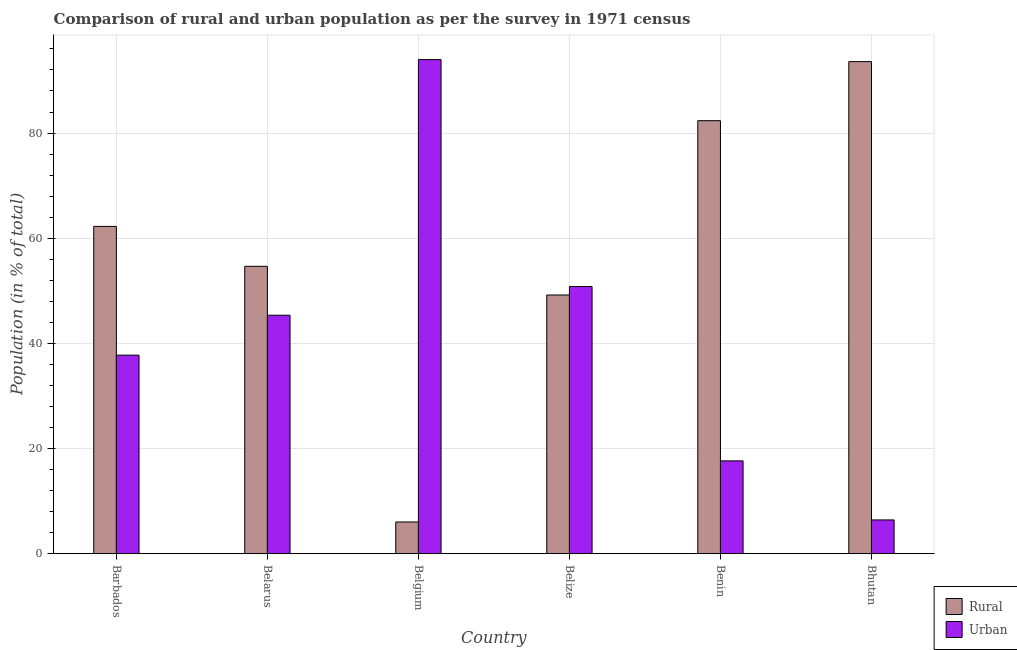How many groups of bars are there?
Make the answer very short. 6. Are the number of bars per tick equal to the number of legend labels?
Make the answer very short. Yes. Are the number of bars on each tick of the X-axis equal?
Your response must be concise. Yes. How many bars are there on the 4th tick from the right?
Give a very brief answer. 2. What is the label of the 5th group of bars from the left?
Your answer should be very brief. Benin. What is the urban population in Belize?
Offer a terse response. 50.8. Across all countries, what is the maximum rural population?
Give a very brief answer. 93.59. Across all countries, what is the minimum rural population?
Ensure brevity in your answer.  6.02. In which country was the urban population maximum?
Ensure brevity in your answer.  Belgium. In which country was the urban population minimum?
Make the answer very short. Bhutan. What is the total rural population in the graph?
Make the answer very short. 348.06. What is the difference between the urban population in Belgium and that in Bhutan?
Offer a terse response. 87.56. What is the difference between the urban population in Benin and the rural population in Belize?
Give a very brief answer. -31.55. What is the average rural population per country?
Offer a terse response. 58.01. What is the difference between the rural population and urban population in Bhutan?
Make the answer very short. 87.17. In how many countries, is the urban population greater than 88 %?
Provide a succinct answer. 1. What is the ratio of the rural population in Belarus to that in Belgium?
Give a very brief answer. 9.07. Is the rural population in Belize less than that in Benin?
Make the answer very short. Yes. What is the difference between the highest and the second highest urban population?
Offer a terse response. 43.17. What is the difference between the highest and the lowest rural population?
Make the answer very short. 87.56. In how many countries, is the rural population greater than the average rural population taken over all countries?
Make the answer very short. 3. What does the 2nd bar from the left in Benin represents?
Your response must be concise. Urban. What does the 1st bar from the right in Barbados represents?
Provide a short and direct response. Urban. How many bars are there?
Your answer should be compact. 12. Are all the bars in the graph horizontal?
Your answer should be compact. No. How many countries are there in the graph?
Keep it short and to the point. 6. Are the values on the major ticks of Y-axis written in scientific E-notation?
Provide a succinct answer. No. Does the graph contain grids?
Your response must be concise. Yes. Where does the legend appear in the graph?
Provide a short and direct response. Bottom right. What is the title of the graph?
Provide a short and direct response. Comparison of rural and urban population as per the survey in 1971 census. Does "Savings" appear as one of the legend labels in the graph?
Offer a very short reply. No. What is the label or title of the X-axis?
Your answer should be very brief. Country. What is the label or title of the Y-axis?
Ensure brevity in your answer.  Population (in % of total). What is the Population (in % of total) in Rural in Barbados?
Keep it short and to the point. 62.24. What is the Population (in % of total) of Urban in Barbados?
Make the answer very short. 37.76. What is the Population (in % of total) in Rural in Belarus?
Your answer should be compact. 54.65. What is the Population (in % of total) in Urban in Belarus?
Your answer should be very brief. 45.35. What is the Population (in % of total) in Rural in Belgium?
Provide a short and direct response. 6.02. What is the Population (in % of total) of Urban in Belgium?
Give a very brief answer. 93.98. What is the Population (in % of total) in Rural in Belize?
Ensure brevity in your answer.  49.2. What is the Population (in % of total) of Urban in Belize?
Offer a very short reply. 50.8. What is the Population (in % of total) of Rural in Benin?
Provide a succinct answer. 82.35. What is the Population (in % of total) of Urban in Benin?
Make the answer very short. 17.65. What is the Population (in % of total) in Rural in Bhutan?
Keep it short and to the point. 93.59. What is the Population (in % of total) of Urban in Bhutan?
Make the answer very short. 6.41. Across all countries, what is the maximum Population (in % of total) of Rural?
Your answer should be very brief. 93.59. Across all countries, what is the maximum Population (in % of total) in Urban?
Provide a short and direct response. 93.98. Across all countries, what is the minimum Population (in % of total) of Rural?
Provide a short and direct response. 6.02. Across all countries, what is the minimum Population (in % of total) in Urban?
Offer a very short reply. 6.41. What is the total Population (in % of total) in Rural in the graph?
Give a very brief answer. 348.06. What is the total Population (in % of total) of Urban in the graph?
Offer a terse response. 251.94. What is the difference between the Population (in % of total) in Rural in Barbados and that in Belarus?
Make the answer very short. 7.59. What is the difference between the Population (in % of total) in Urban in Barbados and that in Belarus?
Give a very brief answer. -7.59. What is the difference between the Population (in % of total) of Rural in Barbados and that in Belgium?
Provide a succinct answer. 56.22. What is the difference between the Population (in % of total) of Urban in Barbados and that in Belgium?
Keep it short and to the point. -56.22. What is the difference between the Population (in % of total) of Rural in Barbados and that in Belize?
Your answer should be compact. 13.05. What is the difference between the Population (in % of total) of Urban in Barbados and that in Belize?
Provide a short and direct response. -13.05. What is the difference between the Population (in % of total) in Rural in Barbados and that in Benin?
Offer a terse response. -20.11. What is the difference between the Population (in % of total) of Urban in Barbados and that in Benin?
Your response must be concise. 20.11. What is the difference between the Population (in % of total) of Rural in Barbados and that in Bhutan?
Provide a short and direct response. -31.34. What is the difference between the Population (in % of total) of Urban in Barbados and that in Bhutan?
Your response must be concise. 31.34. What is the difference between the Population (in % of total) in Rural in Belarus and that in Belgium?
Make the answer very short. 48.63. What is the difference between the Population (in % of total) in Urban in Belarus and that in Belgium?
Provide a succinct answer. -48.63. What is the difference between the Population (in % of total) in Rural in Belarus and that in Belize?
Your response must be concise. 5.46. What is the difference between the Population (in % of total) of Urban in Belarus and that in Belize?
Your response must be concise. -5.46. What is the difference between the Population (in % of total) of Rural in Belarus and that in Benin?
Your answer should be very brief. -27.7. What is the difference between the Population (in % of total) in Urban in Belarus and that in Benin?
Offer a very short reply. 27.7. What is the difference between the Population (in % of total) in Rural in Belarus and that in Bhutan?
Ensure brevity in your answer.  -38.94. What is the difference between the Population (in % of total) of Urban in Belarus and that in Bhutan?
Offer a very short reply. 38.94. What is the difference between the Population (in % of total) in Rural in Belgium and that in Belize?
Give a very brief answer. -43.17. What is the difference between the Population (in % of total) of Urban in Belgium and that in Belize?
Offer a terse response. 43.17. What is the difference between the Population (in % of total) in Rural in Belgium and that in Benin?
Provide a short and direct response. -76.33. What is the difference between the Population (in % of total) of Urban in Belgium and that in Benin?
Give a very brief answer. 76.33. What is the difference between the Population (in % of total) in Rural in Belgium and that in Bhutan?
Give a very brief answer. -87.56. What is the difference between the Population (in % of total) in Urban in Belgium and that in Bhutan?
Provide a short and direct response. 87.56. What is the difference between the Population (in % of total) in Rural in Belize and that in Benin?
Your answer should be very brief. -33.16. What is the difference between the Population (in % of total) in Urban in Belize and that in Benin?
Offer a very short reply. 33.16. What is the difference between the Population (in % of total) of Rural in Belize and that in Bhutan?
Your response must be concise. -44.39. What is the difference between the Population (in % of total) in Urban in Belize and that in Bhutan?
Keep it short and to the point. 44.39. What is the difference between the Population (in % of total) of Rural in Benin and that in Bhutan?
Give a very brief answer. -11.23. What is the difference between the Population (in % of total) of Urban in Benin and that in Bhutan?
Keep it short and to the point. 11.23. What is the difference between the Population (in % of total) in Rural in Barbados and the Population (in % of total) in Urban in Belarus?
Ensure brevity in your answer.  16.9. What is the difference between the Population (in % of total) in Rural in Barbados and the Population (in % of total) in Urban in Belgium?
Offer a very short reply. -31.73. What is the difference between the Population (in % of total) of Rural in Barbados and the Population (in % of total) of Urban in Belize?
Your answer should be very brief. 11.44. What is the difference between the Population (in % of total) of Rural in Barbados and the Population (in % of total) of Urban in Benin?
Provide a short and direct response. 44.6. What is the difference between the Population (in % of total) in Rural in Barbados and the Population (in % of total) in Urban in Bhutan?
Give a very brief answer. 55.83. What is the difference between the Population (in % of total) of Rural in Belarus and the Population (in % of total) of Urban in Belgium?
Your answer should be very brief. -39.33. What is the difference between the Population (in % of total) in Rural in Belarus and the Population (in % of total) in Urban in Belize?
Offer a very short reply. 3.85. What is the difference between the Population (in % of total) in Rural in Belarus and the Population (in % of total) in Urban in Benin?
Your answer should be very brief. 37. What is the difference between the Population (in % of total) of Rural in Belarus and the Population (in % of total) of Urban in Bhutan?
Your response must be concise. 48.24. What is the difference between the Population (in % of total) in Rural in Belgium and the Population (in % of total) in Urban in Belize?
Provide a succinct answer. -44.78. What is the difference between the Population (in % of total) in Rural in Belgium and the Population (in % of total) in Urban in Benin?
Provide a succinct answer. -11.62. What is the difference between the Population (in % of total) in Rural in Belgium and the Population (in % of total) in Urban in Bhutan?
Offer a terse response. -0.39. What is the difference between the Population (in % of total) in Rural in Belize and the Population (in % of total) in Urban in Benin?
Provide a succinct answer. 31.55. What is the difference between the Population (in % of total) in Rural in Belize and the Population (in % of total) in Urban in Bhutan?
Keep it short and to the point. 42.78. What is the difference between the Population (in % of total) of Rural in Benin and the Population (in % of total) of Urban in Bhutan?
Offer a terse response. 75.94. What is the average Population (in % of total) in Rural per country?
Provide a short and direct response. 58.01. What is the average Population (in % of total) in Urban per country?
Provide a succinct answer. 41.99. What is the difference between the Population (in % of total) in Rural and Population (in % of total) in Urban in Barbados?
Provide a short and direct response. 24.49. What is the difference between the Population (in % of total) of Rural and Population (in % of total) of Urban in Belarus?
Provide a succinct answer. 9.3. What is the difference between the Population (in % of total) in Rural and Population (in % of total) in Urban in Belgium?
Your answer should be compact. -87.95. What is the difference between the Population (in % of total) of Rural and Population (in % of total) of Urban in Belize?
Make the answer very short. -1.61. What is the difference between the Population (in % of total) of Rural and Population (in % of total) of Urban in Benin?
Offer a very short reply. 64.71. What is the difference between the Population (in % of total) in Rural and Population (in % of total) in Urban in Bhutan?
Provide a short and direct response. 87.17. What is the ratio of the Population (in % of total) in Rural in Barbados to that in Belarus?
Offer a very short reply. 1.14. What is the ratio of the Population (in % of total) in Urban in Barbados to that in Belarus?
Keep it short and to the point. 0.83. What is the ratio of the Population (in % of total) in Rural in Barbados to that in Belgium?
Ensure brevity in your answer.  10.33. What is the ratio of the Population (in % of total) in Urban in Barbados to that in Belgium?
Ensure brevity in your answer.  0.4. What is the ratio of the Population (in % of total) in Rural in Barbados to that in Belize?
Give a very brief answer. 1.27. What is the ratio of the Population (in % of total) in Urban in Barbados to that in Belize?
Make the answer very short. 0.74. What is the ratio of the Population (in % of total) of Rural in Barbados to that in Benin?
Offer a very short reply. 0.76. What is the ratio of the Population (in % of total) in Urban in Barbados to that in Benin?
Offer a very short reply. 2.14. What is the ratio of the Population (in % of total) of Rural in Barbados to that in Bhutan?
Provide a short and direct response. 0.67. What is the ratio of the Population (in % of total) of Urban in Barbados to that in Bhutan?
Keep it short and to the point. 5.89. What is the ratio of the Population (in % of total) of Rural in Belarus to that in Belgium?
Your answer should be compact. 9.07. What is the ratio of the Population (in % of total) in Urban in Belarus to that in Belgium?
Ensure brevity in your answer.  0.48. What is the ratio of the Population (in % of total) in Rural in Belarus to that in Belize?
Offer a very short reply. 1.11. What is the ratio of the Population (in % of total) in Urban in Belarus to that in Belize?
Give a very brief answer. 0.89. What is the ratio of the Population (in % of total) in Rural in Belarus to that in Benin?
Provide a succinct answer. 0.66. What is the ratio of the Population (in % of total) in Urban in Belarus to that in Benin?
Provide a succinct answer. 2.57. What is the ratio of the Population (in % of total) in Rural in Belarus to that in Bhutan?
Make the answer very short. 0.58. What is the ratio of the Population (in % of total) of Urban in Belarus to that in Bhutan?
Keep it short and to the point. 7.07. What is the ratio of the Population (in % of total) in Rural in Belgium to that in Belize?
Your answer should be compact. 0.12. What is the ratio of the Population (in % of total) of Urban in Belgium to that in Belize?
Your response must be concise. 1.85. What is the ratio of the Population (in % of total) in Rural in Belgium to that in Benin?
Provide a succinct answer. 0.07. What is the ratio of the Population (in % of total) in Urban in Belgium to that in Benin?
Provide a short and direct response. 5.33. What is the ratio of the Population (in % of total) in Rural in Belgium to that in Bhutan?
Your answer should be compact. 0.06. What is the ratio of the Population (in % of total) of Urban in Belgium to that in Bhutan?
Give a very brief answer. 14.65. What is the ratio of the Population (in % of total) of Rural in Belize to that in Benin?
Your answer should be very brief. 0.6. What is the ratio of the Population (in % of total) of Urban in Belize to that in Benin?
Make the answer very short. 2.88. What is the ratio of the Population (in % of total) of Rural in Belize to that in Bhutan?
Your answer should be compact. 0.53. What is the ratio of the Population (in % of total) of Urban in Belize to that in Bhutan?
Ensure brevity in your answer.  7.92. What is the ratio of the Population (in % of total) in Rural in Benin to that in Bhutan?
Your answer should be very brief. 0.88. What is the ratio of the Population (in % of total) of Urban in Benin to that in Bhutan?
Keep it short and to the point. 2.75. What is the difference between the highest and the second highest Population (in % of total) of Rural?
Your answer should be compact. 11.23. What is the difference between the highest and the second highest Population (in % of total) of Urban?
Give a very brief answer. 43.17. What is the difference between the highest and the lowest Population (in % of total) of Rural?
Your answer should be very brief. 87.56. What is the difference between the highest and the lowest Population (in % of total) in Urban?
Your response must be concise. 87.56. 